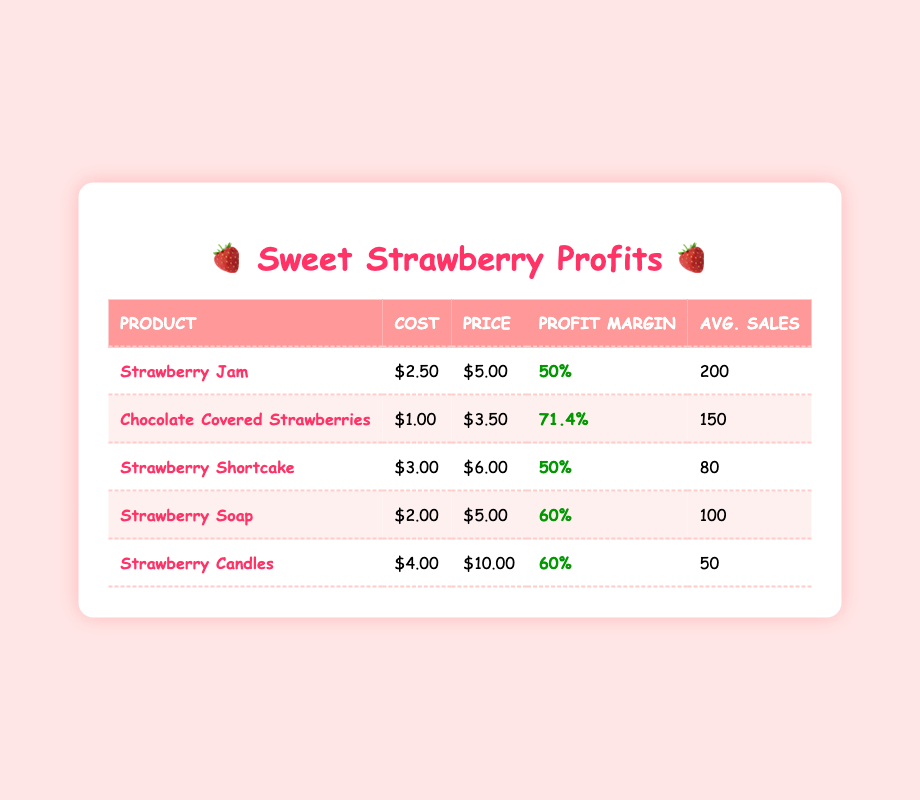What is the profit margin percentage for Strawberry Soap? The profit margin percentage for Strawberry Soap is listed in the table under the "Profit Margin" column, specifically for the item "Strawberry Soap." It shows a profit margin percentage of 60%.
Answer: 60% Which product has the highest average sales per festival? The average sales per festival values are provided in the table. By comparing them, Chocolate Covered Strawberries have the highest average sales with 150 units sold.
Answer: Chocolate Covered Strawberries How much more is the selling price of Strawberry Jam compared to its cost of goods sold? The selling price of Strawberry Jam is $5.00, and its cost of goods sold is $2.50. The difference is calculated as $5.00 - $2.50 = $2.50.
Answer: $2.50 Is the profit margin for Strawberry Shortcake equal to that of Strawberry Jam? The profit margin for Strawberry Shortcake is 50%, while for Strawberry Jam, it is also 50%. Since both values are equal, the statement is true.
Answer: Yes What is the total profit margin percentage of all products combined? First, sum the profit margins of all products: 50 + 71.4 + 50 + 60 + 60 = 291. There are 5 products, so the average profit margin is 291 / 5 = 58.2%.
Answer: 58.2% How much more does it cost to produce Strawberry Candles compared to Chocolate Covered Strawberries? The cost of goods sold for Strawberry Candles is $4.00, and for Chocolate Covered Strawberries, it's $1.00. The difference is $4.00 - $1.00 = $3.00.
Answer: $3.00 Which product has the lowest profit margin percentage? By analyzing the profit margin percentages in the table, both Strawberry Jam and Strawberry Shortcake share the lowest profit margin percentage of 50%.
Answer: Strawberry Jam and Strawberry Shortcake If we sold all average sales of the products, what would be the total revenue? The total revenue is calculated by summing products of selling prices and their average sales: (5.00 * 200) + (3.50 * 150) + (6.00 * 80) + (5.00 * 100) + (10.00 * 50) = 1000 + 525 + 480 + 500 + 500 = 3005.
Answer: $3005 What is the selling price of Strawberry Shortcake? The selling price for Strawberry Shortcake is provided directly in the "Price" column for that product in the table, which is $6.00.
Answer: $6.00 